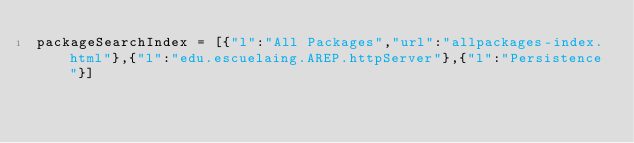Convert code to text. <code><loc_0><loc_0><loc_500><loc_500><_JavaScript_>packageSearchIndex = [{"l":"All Packages","url":"allpackages-index.html"},{"l":"edu.escuelaing.AREP.httpServer"},{"l":"Persistence"}]</code> 